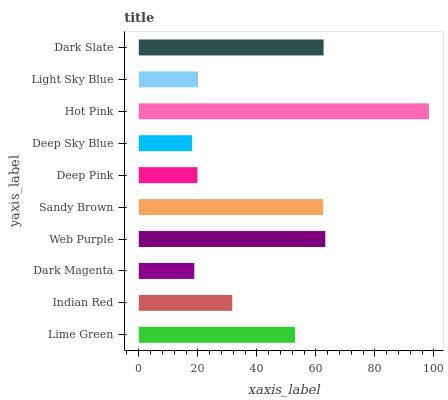Is Deep Sky Blue the minimum?
Answer yes or no. Yes. Is Hot Pink the maximum?
Answer yes or no. Yes. Is Indian Red the minimum?
Answer yes or no. No. Is Indian Red the maximum?
Answer yes or no. No. Is Lime Green greater than Indian Red?
Answer yes or no. Yes. Is Indian Red less than Lime Green?
Answer yes or no. Yes. Is Indian Red greater than Lime Green?
Answer yes or no. No. Is Lime Green less than Indian Red?
Answer yes or no. No. Is Lime Green the high median?
Answer yes or no. Yes. Is Indian Red the low median?
Answer yes or no. Yes. Is Indian Red the high median?
Answer yes or no. No. Is Dark Magenta the low median?
Answer yes or no. No. 